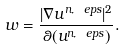Convert formula to latex. <formula><loc_0><loc_0><loc_500><loc_500>w = \frac { | \nabla u ^ { n , \ e p s } | ^ { 2 } } { \theta ( u ^ { n , \ e p s } ) } .</formula> 